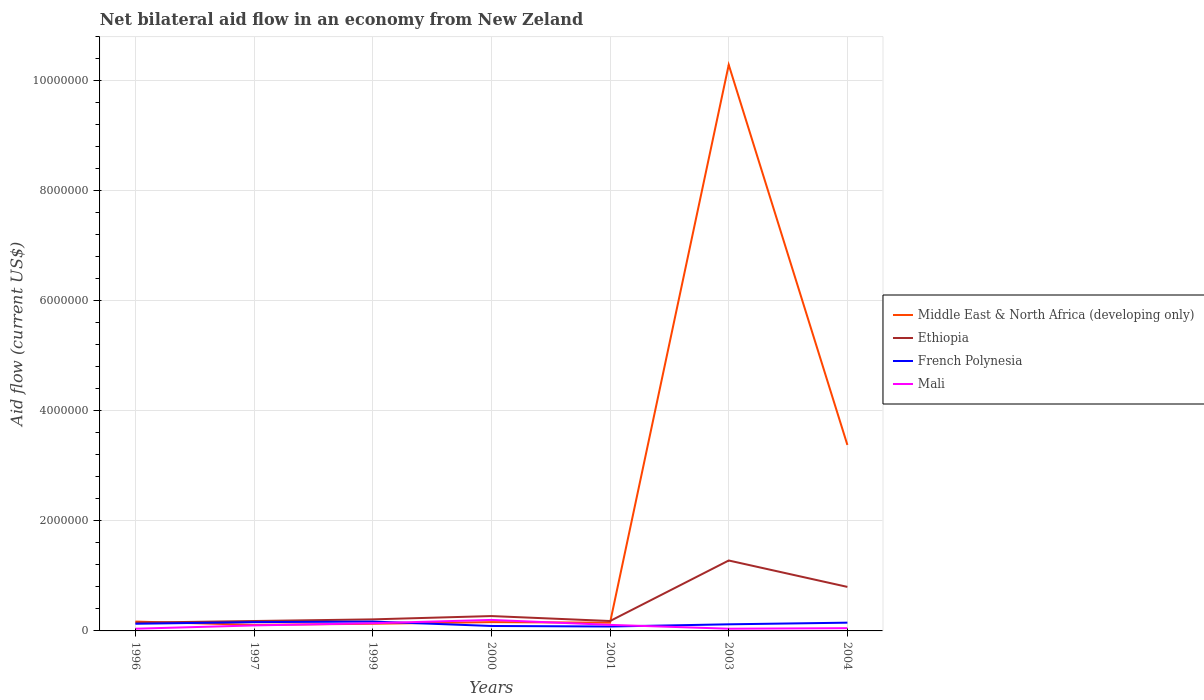Does the line corresponding to French Polynesia intersect with the line corresponding to Mali?
Your response must be concise. Yes. In which year was the net bilateral aid flow in Ethiopia maximum?
Offer a terse response. 1996. What is the difference between the highest and the second highest net bilateral aid flow in Middle East & North Africa (developing only)?
Provide a short and direct response. 1.02e+07. Is the net bilateral aid flow in Mali strictly greater than the net bilateral aid flow in Ethiopia over the years?
Give a very brief answer. Yes. How many lines are there?
Provide a short and direct response. 4. How many years are there in the graph?
Make the answer very short. 7. What is the difference between two consecutive major ticks on the Y-axis?
Give a very brief answer. 2.00e+06. Does the graph contain grids?
Provide a succinct answer. Yes. Where does the legend appear in the graph?
Provide a short and direct response. Center right. How are the legend labels stacked?
Your answer should be compact. Vertical. What is the title of the graph?
Offer a very short reply. Net bilateral aid flow in an economy from New Zeland. What is the label or title of the Y-axis?
Your response must be concise. Aid flow (current US$). What is the Aid flow (current US$) of Middle East & North Africa (developing only) in 1996?
Offer a terse response. 1.70e+05. What is the Aid flow (current US$) of Ethiopia in 1996?
Provide a succinct answer. 1.50e+05. What is the Aid flow (current US$) in Mali in 1996?
Offer a terse response. 4.00e+04. What is the Aid flow (current US$) in Mali in 1997?
Provide a short and direct response. 1.00e+05. What is the Aid flow (current US$) of Ethiopia in 1999?
Ensure brevity in your answer.  2.10e+05. What is the Aid flow (current US$) of French Polynesia in 1999?
Keep it short and to the point. 1.70e+05. What is the Aid flow (current US$) of Middle East & North Africa (developing only) in 2000?
Your response must be concise. 1.60e+05. What is the Aid flow (current US$) of French Polynesia in 2000?
Offer a terse response. 9.00e+04. What is the Aid flow (current US$) in Middle East & North Africa (developing only) in 2001?
Provide a short and direct response. 1.50e+05. What is the Aid flow (current US$) of Ethiopia in 2001?
Your answer should be compact. 1.80e+05. What is the Aid flow (current US$) of French Polynesia in 2001?
Ensure brevity in your answer.  8.00e+04. What is the Aid flow (current US$) in Mali in 2001?
Ensure brevity in your answer.  1.10e+05. What is the Aid flow (current US$) of Middle East & North Africa (developing only) in 2003?
Offer a terse response. 1.03e+07. What is the Aid flow (current US$) of Ethiopia in 2003?
Your answer should be very brief. 1.28e+06. What is the Aid flow (current US$) in Middle East & North Africa (developing only) in 2004?
Make the answer very short. 3.38e+06. What is the Aid flow (current US$) of French Polynesia in 2004?
Give a very brief answer. 1.50e+05. Across all years, what is the maximum Aid flow (current US$) in Middle East & North Africa (developing only)?
Your answer should be very brief. 1.03e+07. Across all years, what is the maximum Aid flow (current US$) of Ethiopia?
Your answer should be very brief. 1.28e+06. Across all years, what is the maximum Aid flow (current US$) in French Polynesia?
Offer a terse response. 1.70e+05. Across all years, what is the maximum Aid flow (current US$) of Mali?
Make the answer very short. 2.00e+05. Across all years, what is the minimum Aid flow (current US$) in Middle East & North Africa (developing only)?
Offer a terse response. 1.10e+05. Across all years, what is the minimum Aid flow (current US$) in Ethiopia?
Make the answer very short. 1.50e+05. Across all years, what is the minimum Aid flow (current US$) of French Polynesia?
Ensure brevity in your answer.  8.00e+04. What is the total Aid flow (current US$) of Middle East & North Africa (developing only) in the graph?
Your answer should be compact. 1.44e+07. What is the total Aid flow (current US$) in Ethiopia in the graph?
Make the answer very short. 3.07e+06. What is the total Aid flow (current US$) in Mali in the graph?
Your response must be concise. 6.80e+05. What is the difference between the Aid flow (current US$) in Middle East & North Africa (developing only) in 1996 and that in 1997?
Keep it short and to the point. 6.00e+04. What is the difference between the Aid flow (current US$) of Ethiopia in 1996 and that in 1997?
Your answer should be very brief. -3.00e+04. What is the difference between the Aid flow (current US$) in French Polynesia in 1996 and that in 1997?
Your answer should be very brief. -3.00e+04. What is the difference between the Aid flow (current US$) in Middle East & North Africa (developing only) in 1996 and that in 1999?
Your response must be concise. 4.00e+04. What is the difference between the Aid flow (current US$) of Mali in 1996 and that in 1999?
Offer a very short reply. -1.00e+05. What is the difference between the Aid flow (current US$) in Middle East & North Africa (developing only) in 1996 and that in 2000?
Your response must be concise. 10000. What is the difference between the Aid flow (current US$) in Ethiopia in 1996 and that in 2000?
Keep it short and to the point. -1.20e+05. What is the difference between the Aid flow (current US$) of French Polynesia in 1996 and that in 2000?
Give a very brief answer. 4.00e+04. What is the difference between the Aid flow (current US$) of Mali in 1996 and that in 2000?
Keep it short and to the point. -1.60e+05. What is the difference between the Aid flow (current US$) in Middle East & North Africa (developing only) in 1996 and that in 2001?
Offer a very short reply. 2.00e+04. What is the difference between the Aid flow (current US$) of Mali in 1996 and that in 2001?
Give a very brief answer. -7.00e+04. What is the difference between the Aid flow (current US$) in Middle East & North Africa (developing only) in 1996 and that in 2003?
Offer a terse response. -1.01e+07. What is the difference between the Aid flow (current US$) in Ethiopia in 1996 and that in 2003?
Ensure brevity in your answer.  -1.13e+06. What is the difference between the Aid flow (current US$) in Mali in 1996 and that in 2003?
Provide a short and direct response. 0. What is the difference between the Aid flow (current US$) of Middle East & North Africa (developing only) in 1996 and that in 2004?
Make the answer very short. -3.21e+06. What is the difference between the Aid flow (current US$) of Ethiopia in 1996 and that in 2004?
Your answer should be compact. -6.50e+05. What is the difference between the Aid flow (current US$) of French Polynesia in 1996 and that in 2004?
Provide a succinct answer. -2.00e+04. What is the difference between the Aid flow (current US$) of Middle East & North Africa (developing only) in 1997 and that in 1999?
Offer a terse response. -2.00e+04. What is the difference between the Aid flow (current US$) in Ethiopia in 1997 and that in 1999?
Offer a terse response. -3.00e+04. What is the difference between the Aid flow (current US$) of French Polynesia in 1997 and that in 1999?
Ensure brevity in your answer.  -10000. What is the difference between the Aid flow (current US$) in Middle East & North Africa (developing only) in 1997 and that in 2000?
Ensure brevity in your answer.  -5.00e+04. What is the difference between the Aid flow (current US$) of Ethiopia in 1997 and that in 2000?
Ensure brevity in your answer.  -9.00e+04. What is the difference between the Aid flow (current US$) in Mali in 1997 and that in 2000?
Offer a very short reply. -1.00e+05. What is the difference between the Aid flow (current US$) of Middle East & North Africa (developing only) in 1997 and that in 2001?
Your answer should be compact. -4.00e+04. What is the difference between the Aid flow (current US$) in Ethiopia in 1997 and that in 2001?
Provide a succinct answer. 0. What is the difference between the Aid flow (current US$) of French Polynesia in 1997 and that in 2001?
Offer a very short reply. 8.00e+04. What is the difference between the Aid flow (current US$) in Mali in 1997 and that in 2001?
Offer a terse response. -10000. What is the difference between the Aid flow (current US$) of Middle East & North Africa (developing only) in 1997 and that in 2003?
Ensure brevity in your answer.  -1.02e+07. What is the difference between the Aid flow (current US$) of Ethiopia in 1997 and that in 2003?
Give a very brief answer. -1.10e+06. What is the difference between the Aid flow (current US$) of Middle East & North Africa (developing only) in 1997 and that in 2004?
Your answer should be very brief. -3.27e+06. What is the difference between the Aid flow (current US$) in Ethiopia in 1997 and that in 2004?
Offer a very short reply. -6.20e+05. What is the difference between the Aid flow (current US$) of Mali in 1997 and that in 2004?
Offer a very short reply. 5.00e+04. What is the difference between the Aid flow (current US$) in Ethiopia in 1999 and that in 2000?
Offer a very short reply. -6.00e+04. What is the difference between the Aid flow (current US$) of French Polynesia in 1999 and that in 2000?
Offer a very short reply. 8.00e+04. What is the difference between the Aid flow (current US$) of Middle East & North Africa (developing only) in 1999 and that in 2001?
Give a very brief answer. -2.00e+04. What is the difference between the Aid flow (current US$) in Ethiopia in 1999 and that in 2001?
Offer a terse response. 3.00e+04. What is the difference between the Aid flow (current US$) of French Polynesia in 1999 and that in 2001?
Your response must be concise. 9.00e+04. What is the difference between the Aid flow (current US$) of Mali in 1999 and that in 2001?
Your answer should be compact. 3.00e+04. What is the difference between the Aid flow (current US$) in Middle East & North Africa (developing only) in 1999 and that in 2003?
Provide a short and direct response. -1.02e+07. What is the difference between the Aid flow (current US$) in Ethiopia in 1999 and that in 2003?
Give a very brief answer. -1.07e+06. What is the difference between the Aid flow (current US$) in Mali in 1999 and that in 2003?
Offer a very short reply. 1.00e+05. What is the difference between the Aid flow (current US$) in Middle East & North Africa (developing only) in 1999 and that in 2004?
Offer a terse response. -3.25e+06. What is the difference between the Aid flow (current US$) in Ethiopia in 1999 and that in 2004?
Give a very brief answer. -5.90e+05. What is the difference between the Aid flow (current US$) of French Polynesia in 1999 and that in 2004?
Keep it short and to the point. 2.00e+04. What is the difference between the Aid flow (current US$) of Mali in 1999 and that in 2004?
Ensure brevity in your answer.  9.00e+04. What is the difference between the Aid flow (current US$) in Middle East & North Africa (developing only) in 2000 and that in 2001?
Offer a terse response. 10000. What is the difference between the Aid flow (current US$) in Ethiopia in 2000 and that in 2001?
Give a very brief answer. 9.00e+04. What is the difference between the Aid flow (current US$) in French Polynesia in 2000 and that in 2001?
Ensure brevity in your answer.  10000. What is the difference between the Aid flow (current US$) in Middle East & North Africa (developing only) in 2000 and that in 2003?
Provide a short and direct response. -1.01e+07. What is the difference between the Aid flow (current US$) in Ethiopia in 2000 and that in 2003?
Offer a terse response. -1.01e+06. What is the difference between the Aid flow (current US$) of French Polynesia in 2000 and that in 2003?
Your response must be concise. -3.00e+04. What is the difference between the Aid flow (current US$) in Middle East & North Africa (developing only) in 2000 and that in 2004?
Give a very brief answer. -3.22e+06. What is the difference between the Aid flow (current US$) of Ethiopia in 2000 and that in 2004?
Ensure brevity in your answer.  -5.30e+05. What is the difference between the Aid flow (current US$) in French Polynesia in 2000 and that in 2004?
Give a very brief answer. -6.00e+04. What is the difference between the Aid flow (current US$) in Middle East & North Africa (developing only) in 2001 and that in 2003?
Offer a terse response. -1.01e+07. What is the difference between the Aid flow (current US$) in Ethiopia in 2001 and that in 2003?
Your answer should be very brief. -1.10e+06. What is the difference between the Aid flow (current US$) of Middle East & North Africa (developing only) in 2001 and that in 2004?
Make the answer very short. -3.23e+06. What is the difference between the Aid flow (current US$) in Ethiopia in 2001 and that in 2004?
Your response must be concise. -6.20e+05. What is the difference between the Aid flow (current US$) in French Polynesia in 2001 and that in 2004?
Give a very brief answer. -7.00e+04. What is the difference between the Aid flow (current US$) of Middle East & North Africa (developing only) in 2003 and that in 2004?
Offer a terse response. 6.91e+06. What is the difference between the Aid flow (current US$) in Mali in 2003 and that in 2004?
Ensure brevity in your answer.  -10000. What is the difference between the Aid flow (current US$) in Middle East & North Africa (developing only) in 1996 and the Aid flow (current US$) in French Polynesia in 1997?
Your answer should be very brief. 10000. What is the difference between the Aid flow (current US$) of Middle East & North Africa (developing only) in 1996 and the Aid flow (current US$) of Mali in 1997?
Your answer should be compact. 7.00e+04. What is the difference between the Aid flow (current US$) in Ethiopia in 1996 and the Aid flow (current US$) in Mali in 1997?
Give a very brief answer. 5.00e+04. What is the difference between the Aid flow (current US$) in Middle East & North Africa (developing only) in 1996 and the Aid flow (current US$) in French Polynesia in 1999?
Offer a terse response. 0. What is the difference between the Aid flow (current US$) in French Polynesia in 1996 and the Aid flow (current US$) in Mali in 1999?
Ensure brevity in your answer.  -10000. What is the difference between the Aid flow (current US$) of Middle East & North Africa (developing only) in 1996 and the Aid flow (current US$) of Ethiopia in 2000?
Make the answer very short. -1.00e+05. What is the difference between the Aid flow (current US$) in Middle East & North Africa (developing only) in 1996 and the Aid flow (current US$) in French Polynesia in 2000?
Provide a succinct answer. 8.00e+04. What is the difference between the Aid flow (current US$) of Ethiopia in 1996 and the Aid flow (current US$) of French Polynesia in 2000?
Ensure brevity in your answer.  6.00e+04. What is the difference between the Aid flow (current US$) of Middle East & North Africa (developing only) in 1996 and the Aid flow (current US$) of Ethiopia in 2001?
Offer a terse response. -10000. What is the difference between the Aid flow (current US$) in Middle East & North Africa (developing only) in 1996 and the Aid flow (current US$) in French Polynesia in 2001?
Offer a very short reply. 9.00e+04. What is the difference between the Aid flow (current US$) in Ethiopia in 1996 and the Aid flow (current US$) in French Polynesia in 2001?
Provide a succinct answer. 7.00e+04. What is the difference between the Aid flow (current US$) in French Polynesia in 1996 and the Aid flow (current US$) in Mali in 2001?
Make the answer very short. 2.00e+04. What is the difference between the Aid flow (current US$) in Middle East & North Africa (developing only) in 1996 and the Aid flow (current US$) in Ethiopia in 2003?
Make the answer very short. -1.11e+06. What is the difference between the Aid flow (current US$) in Middle East & North Africa (developing only) in 1996 and the Aid flow (current US$) in Ethiopia in 2004?
Make the answer very short. -6.30e+05. What is the difference between the Aid flow (current US$) in Middle East & North Africa (developing only) in 1996 and the Aid flow (current US$) in Mali in 2004?
Ensure brevity in your answer.  1.20e+05. What is the difference between the Aid flow (current US$) of French Polynesia in 1996 and the Aid flow (current US$) of Mali in 2004?
Ensure brevity in your answer.  8.00e+04. What is the difference between the Aid flow (current US$) in Middle East & North Africa (developing only) in 1997 and the Aid flow (current US$) in Ethiopia in 1999?
Your answer should be very brief. -1.00e+05. What is the difference between the Aid flow (current US$) in Middle East & North Africa (developing only) in 1997 and the Aid flow (current US$) in French Polynesia in 1999?
Provide a succinct answer. -6.00e+04. What is the difference between the Aid flow (current US$) of Middle East & North Africa (developing only) in 1997 and the Aid flow (current US$) of Mali in 1999?
Ensure brevity in your answer.  -3.00e+04. What is the difference between the Aid flow (current US$) of Ethiopia in 1997 and the Aid flow (current US$) of French Polynesia in 1999?
Keep it short and to the point. 10000. What is the difference between the Aid flow (current US$) in Ethiopia in 1997 and the Aid flow (current US$) in Mali in 1999?
Make the answer very short. 4.00e+04. What is the difference between the Aid flow (current US$) in Middle East & North Africa (developing only) in 1997 and the Aid flow (current US$) in Ethiopia in 2000?
Ensure brevity in your answer.  -1.60e+05. What is the difference between the Aid flow (current US$) of Middle East & North Africa (developing only) in 1997 and the Aid flow (current US$) of French Polynesia in 2000?
Offer a terse response. 2.00e+04. What is the difference between the Aid flow (current US$) in Middle East & North Africa (developing only) in 1997 and the Aid flow (current US$) in Mali in 2000?
Keep it short and to the point. -9.00e+04. What is the difference between the Aid flow (current US$) in Ethiopia in 1997 and the Aid flow (current US$) in French Polynesia in 2000?
Make the answer very short. 9.00e+04. What is the difference between the Aid flow (current US$) in Middle East & North Africa (developing only) in 1997 and the Aid flow (current US$) in French Polynesia in 2001?
Ensure brevity in your answer.  3.00e+04. What is the difference between the Aid flow (current US$) in French Polynesia in 1997 and the Aid flow (current US$) in Mali in 2001?
Provide a short and direct response. 5.00e+04. What is the difference between the Aid flow (current US$) in Middle East & North Africa (developing only) in 1997 and the Aid flow (current US$) in Ethiopia in 2003?
Your response must be concise. -1.17e+06. What is the difference between the Aid flow (current US$) of Middle East & North Africa (developing only) in 1997 and the Aid flow (current US$) of French Polynesia in 2003?
Provide a succinct answer. -10000. What is the difference between the Aid flow (current US$) of Ethiopia in 1997 and the Aid flow (current US$) of Mali in 2003?
Provide a short and direct response. 1.40e+05. What is the difference between the Aid flow (current US$) of French Polynesia in 1997 and the Aid flow (current US$) of Mali in 2003?
Provide a short and direct response. 1.20e+05. What is the difference between the Aid flow (current US$) in Middle East & North Africa (developing only) in 1997 and the Aid flow (current US$) in Ethiopia in 2004?
Make the answer very short. -6.90e+05. What is the difference between the Aid flow (current US$) of Ethiopia in 1997 and the Aid flow (current US$) of Mali in 2004?
Your response must be concise. 1.30e+05. What is the difference between the Aid flow (current US$) of Middle East & North Africa (developing only) in 1999 and the Aid flow (current US$) of Ethiopia in 2000?
Provide a succinct answer. -1.40e+05. What is the difference between the Aid flow (current US$) of Middle East & North Africa (developing only) in 1999 and the Aid flow (current US$) of Mali in 2000?
Ensure brevity in your answer.  -7.00e+04. What is the difference between the Aid flow (current US$) of Ethiopia in 1999 and the Aid flow (current US$) of French Polynesia in 2000?
Provide a short and direct response. 1.20e+05. What is the difference between the Aid flow (current US$) in French Polynesia in 1999 and the Aid flow (current US$) in Mali in 2000?
Your answer should be compact. -3.00e+04. What is the difference between the Aid flow (current US$) of Ethiopia in 1999 and the Aid flow (current US$) of Mali in 2001?
Give a very brief answer. 1.00e+05. What is the difference between the Aid flow (current US$) in Middle East & North Africa (developing only) in 1999 and the Aid flow (current US$) in Ethiopia in 2003?
Ensure brevity in your answer.  -1.15e+06. What is the difference between the Aid flow (current US$) of Middle East & North Africa (developing only) in 1999 and the Aid flow (current US$) of French Polynesia in 2003?
Give a very brief answer. 10000. What is the difference between the Aid flow (current US$) in Middle East & North Africa (developing only) in 1999 and the Aid flow (current US$) in Mali in 2003?
Offer a very short reply. 9.00e+04. What is the difference between the Aid flow (current US$) of Middle East & North Africa (developing only) in 1999 and the Aid flow (current US$) of Ethiopia in 2004?
Ensure brevity in your answer.  -6.70e+05. What is the difference between the Aid flow (current US$) of Middle East & North Africa (developing only) in 1999 and the Aid flow (current US$) of Mali in 2004?
Offer a terse response. 8.00e+04. What is the difference between the Aid flow (current US$) in Middle East & North Africa (developing only) in 2000 and the Aid flow (current US$) in French Polynesia in 2001?
Keep it short and to the point. 8.00e+04. What is the difference between the Aid flow (current US$) of French Polynesia in 2000 and the Aid flow (current US$) of Mali in 2001?
Ensure brevity in your answer.  -2.00e+04. What is the difference between the Aid flow (current US$) of Middle East & North Africa (developing only) in 2000 and the Aid flow (current US$) of Ethiopia in 2003?
Offer a very short reply. -1.12e+06. What is the difference between the Aid flow (current US$) of Middle East & North Africa (developing only) in 2000 and the Aid flow (current US$) of Mali in 2003?
Ensure brevity in your answer.  1.20e+05. What is the difference between the Aid flow (current US$) in Ethiopia in 2000 and the Aid flow (current US$) in French Polynesia in 2003?
Your answer should be very brief. 1.50e+05. What is the difference between the Aid flow (current US$) in French Polynesia in 2000 and the Aid flow (current US$) in Mali in 2003?
Give a very brief answer. 5.00e+04. What is the difference between the Aid flow (current US$) in Middle East & North Africa (developing only) in 2000 and the Aid flow (current US$) in Ethiopia in 2004?
Give a very brief answer. -6.40e+05. What is the difference between the Aid flow (current US$) of Middle East & North Africa (developing only) in 2000 and the Aid flow (current US$) of Mali in 2004?
Your answer should be compact. 1.10e+05. What is the difference between the Aid flow (current US$) of Ethiopia in 2000 and the Aid flow (current US$) of French Polynesia in 2004?
Your response must be concise. 1.20e+05. What is the difference between the Aid flow (current US$) in Ethiopia in 2000 and the Aid flow (current US$) in Mali in 2004?
Your response must be concise. 2.20e+05. What is the difference between the Aid flow (current US$) in Middle East & North Africa (developing only) in 2001 and the Aid flow (current US$) in Ethiopia in 2003?
Offer a terse response. -1.13e+06. What is the difference between the Aid flow (current US$) of Middle East & North Africa (developing only) in 2001 and the Aid flow (current US$) of Ethiopia in 2004?
Make the answer very short. -6.50e+05. What is the difference between the Aid flow (current US$) of Middle East & North Africa (developing only) in 2001 and the Aid flow (current US$) of Mali in 2004?
Your response must be concise. 1.00e+05. What is the difference between the Aid flow (current US$) in Ethiopia in 2001 and the Aid flow (current US$) in French Polynesia in 2004?
Your response must be concise. 3.00e+04. What is the difference between the Aid flow (current US$) of Ethiopia in 2001 and the Aid flow (current US$) of Mali in 2004?
Your answer should be compact. 1.30e+05. What is the difference between the Aid flow (current US$) of French Polynesia in 2001 and the Aid flow (current US$) of Mali in 2004?
Ensure brevity in your answer.  3.00e+04. What is the difference between the Aid flow (current US$) of Middle East & North Africa (developing only) in 2003 and the Aid flow (current US$) of Ethiopia in 2004?
Offer a very short reply. 9.49e+06. What is the difference between the Aid flow (current US$) in Middle East & North Africa (developing only) in 2003 and the Aid flow (current US$) in French Polynesia in 2004?
Offer a terse response. 1.01e+07. What is the difference between the Aid flow (current US$) in Middle East & North Africa (developing only) in 2003 and the Aid flow (current US$) in Mali in 2004?
Your answer should be very brief. 1.02e+07. What is the difference between the Aid flow (current US$) in Ethiopia in 2003 and the Aid flow (current US$) in French Polynesia in 2004?
Your answer should be very brief. 1.13e+06. What is the difference between the Aid flow (current US$) in Ethiopia in 2003 and the Aid flow (current US$) in Mali in 2004?
Provide a short and direct response. 1.23e+06. What is the difference between the Aid flow (current US$) in French Polynesia in 2003 and the Aid flow (current US$) in Mali in 2004?
Provide a succinct answer. 7.00e+04. What is the average Aid flow (current US$) of Middle East & North Africa (developing only) per year?
Offer a terse response. 2.06e+06. What is the average Aid flow (current US$) in Ethiopia per year?
Provide a succinct answer. 4.39e+05. What is the average Aid flow (current US$) in French Polynesia per year?
Your answer should be compact. 1.29e+05. What is the average Aid flow (current US$) of Mali per year?
Your answer should be compact. 9.71e+04. In the year 1996, what is the difference between the Aid flow (current US$) in Middle East & North Africa (developing only) and Aid flow (current US$) in Mali?
Your response must be concise. 1.30e+05. In the year 1997, what is the difference between the Aid flow (current US$) of Middle East & North Africa (developing only) and Aid flow (current US$) of Ethiopia?
Your answer should be very brief. -7.00e+04. In the year 1997, what is the difference between the Aid flow (current US$) in Middle East & North Africa (developing only) and Aid flow (current US$) in Mali?
Your response must be concise. 10000. In the year 1997, what is the difference between the Aid flow (current US$) of French Polynesia and Aid flow (current US$) of Mali?
Give a very brief answer. 6.00e+04. In the year 1999, what is the difference between the Aid flow (current US$) in Middle East & North Africa (developing only) and Aid flow (current US$) in Mali?
Ensure brevity in your answer.  -10000. In the year 1999, what is the difference between the Aid flow (current US$) of Ethiopia and Aid flow (current US$) of French Polynesia?
Your answer should be compact. 4.00e+04. In the year 1999, what is the difference between the Aid flow (current US$) of French Polynesia and Aid flow (current US$) of Mali?
Your answer should be compact. 3.00e+04. In the year 2000, what is the difference between the Aid flow (current US$) of Middle East & North Africa (developing only) and Aid flow (current US$) of French Polynesia?
Provide a short and direct response. 7.00e+04. In the year 2000, what is the difference between the Aid flow (current US$) of Ethiopia and Aid flow (current US$) of Mali?
Provide a succinct answer. 7.00e+04. In the year 2001, what is the difference between the Aid flow (current US$) in Middle East & North Africa (developing only) and Aid flow (current US$) in Ethiopia?
Your response must be concise. -3.00e+04. In the year 2001, what is the difference between the Aid flow (current US$) of Ethiopia and Aid flow (current US$) of French Polynesia?
Provide a succinct answer. 1.00e+05. In the year 2001, what is the difference between the Aid flow (current US$) of Ethiopia and Aid flow (current US$) of Mali?
Make the answer very short. 7.00e+04. In the year 2001, what is the difference between the Aid flow (current US$) in French Polynesia and Aid flow (current US$) in Mali?
Offer a terse response. -3.00e+04. In the year 2003, what is the difference between the Aid flow (current US$) in Middle East & North Africa (developing only) and Aid flow (current US$) in Ethiopia?
Make the answer very short. 9.01e+06. In the year 2003, what is the difference between the Aid flow (current US$) of Middle East & North Africa (developing only) and Aid flow (current US$) of French Polynesia?
Keep it short and to the point. 1.02e+07. In the year 2003, what is the difference between the Aid flow (current US$) in Middle East & North Africa (developing only) and Aid flow (current US$) in Mali?
Offer a terse response. 1.02e+07. In the year 2003, what is the difference between the Aid flow (current US$) of Ethiopia and Aid flow (current US$) of French Polynesia?
Keep it short and to the point. 1.16e+06. In the year 2003, what is the difference between the Aid flow (current US$) in Ethiopia and Aid flow (current US$) in Mali?
Provide a short and direct response. 1.24e+06. In the year 2004, what is the difference between the Aid flow (current US$) of Middle East & North Africa (developing only) and Aid flow (current US$) of Ethiopia?
Your answer should be very brief. 2.58e+06. In the year 2004, what is the difference between the Aid flow (current US$) of Middle East & North Africa (developing only) and Aid flow (current US$) of French Polynesia?
Give a very brief answer. 3.23e+06. In the year 2004, what is the difference between the Aid flow (current US$) of Middle East & North Africa (developing only) and Aid flow (current US$) of Mali?
Provide a short and direct response. 3.33e+06. In the year 2004, what is the difference between the Aid flow (current US$) of Ethiopia and Aid flow (current US$) of French Polynesia?
Provide a short and direct response. 6.50e+05. In the year 2004, what is the difference between the Aid flow (current US$) of Ethiopia and Aid flow (current US$) of Mali?
Offer a terse response. 7.50e+05. What is the ratio of the Aid flow (current US$) of Middle East & North Africa (developing only) in 1996 to that in 1997?
Your answer should be very brief. 1.55. What is the ratio of the Aid flow (current US$) in French Polynesia in 1996 to that in 1997?
Give a very brief answer. 0.81. What is the ratio of the Aid flow (current US$) in Mali in 1996 to that in 1997?
Keep it short and to the point. 0.4. What is the ratio of the Aid flow (current US$) in Middle East & North Africa (developing only) in 1996 to that in 1999?
Offer a very short reply. 1.31. What is the ratio of the Aid flow (current US$) of Ethiopia in 1996 to that in 1999?
Provide a short and direct response. 0.71. What is the ratio of the Aid flow (current US$) of French Polynesia in 1996 to that in 1999?
Make the answer very short. 0.76. What is the ratio of the Aid flow (current US$) in Mali in 1996 to that in 1999?
Provide a succinct answer. 0.29. What is the ratio of the Aid flow (current US$) of Ethiopia in 1996 to that in 2000?
Your answer should be compact. 0.56. What is the ratio of the Aid flow (current US$) of French Polynesia in 1996 to that in 2000?
Keep it short and to the point. 1.44. What is the ratio of the Aid flow (current US$) of Mali in 1996 to that in 2000?
Your answer should be compact. 0.2. What is the ratio of the Aid flow (current US$) in Middle East & North Africa (developing only) in 1996 to that in 2001?
Offer a very short reply. 1.13. What is the ratio of the Aid flow (current US$) in Ethiopia in 1996 to that in 2001?
Your answer should be compact. 0.83. What is the ratio of the Aid flow (current US$) in French Polynesia in 1996 to that in 2001?
Keep it short and to the point. 1.62. What is the ratio of the Aid flow (current US$) in Mali in 1996 to that in 2001?
Keep it short and to the point. 0.36. What is the ratio of the Aid flow (current US$) of Middle East & North Africa (developing only) in 1996 to that in 2003?
Ensure brevity in your answer.  0.02. What is the ratio of the Aid flow (current US$) in Ethiopia in 1996 to that in 2003?
Give a very brief answer. 0.12. What is the ratio of the Aid flow (current US$) in Middle East & North Africa (developing only) in 1996 to that in 2004?
Make the answer very short. 0.05. What is the ratio of the Aid flow (current US$) of Ethiopia in 1996 to that in 2004?
Offer a very short reply. 0.19. What is the ratio of the Aid flow (current US$) in French Polynesia in 1996 to that in 2004?
Your response must be concise. 0.87. What is the ratio of the Aid flow (current US$) in Middle East & North Africa (developing only) in 1997 to that in 1999?
Your response must be concise. 0.85. What is the ratio of the Aid flow (current US$) in Ethiopia in 1997 to that in 1999?
Your answer should be compact. 0.86. What is the ratio of the Aid flow (current US$) in Mali in 1997 to that in 1999?
Offer a very short reply. 0.71. What is the ratio of the Aid flow (current US$) in Middle East & North Africa (developing only) in 1997 to that in 2000?
Make the answer very short. 0.69. What is the ratio of the Aid flow (current US$) in French Polynesia in 1997 to that in 2000?
Provide a succinct answer. 1.78. What is the ratio of the Aid flow (current US$) of Middle East & North Africa (developing only) in 1997 to that in 2001?
Ensure brevity in your answer.  0.73. What is the ratio of the Aid flow (current US$) of Ethiopia in 1997 to that in 2001?
Provide a short and direct response. 1. What is the ratio of the Aid flow (current US$) in French Polynesia in 1997 to that in 2001?
Ensure brevity in your answer.  2. What is the ratio of the Aid flow (current US$) in Middle East & North Africa (developing only) in 1997 to that in 2003?
Provide a succinct answer. 0.01. What is the ratio of the Aid flow (current US$) in Ethiopia in 1997 to that in 2003?
Offer a very short reply. 0.14. What is the ratio of the Aid flow (current US$) in French Polynesia in 1997 to that in 2003?
Provide a short and direct response. 1.33. What is the ratio of the Aid flow (current US$) in Middle East & North Africa (developing only) in 1997 to that in 2004?
Your response must be concise. 0.03. What is the ratio of the Aid flow (current US$) of Ethiopia in 1997 to that in 2004?
Make the answer very short. 0.23. What is the ratio of the Aid flow (current US$) of French Polynesia in 1997 to that in 2004?
Your response must be concise. 1.07. What is the ratio of the Aid flow (current US$) in Mali in 1997 to that in 2004?
Offer a terse response. 2. What is the ratio of the Aid flow (current US$) in Middle East & North Africa (developing only) in 1999 to that in 2000?
Give a very brief answer. 0.81. What is the ratio of the Aid flow (current US$) of Ethiopia in 1999 to that in 2000?
Keep it short and to the point. 0.78. What is the ratio of the Aid flow (current US$) of French Polynesia in 1999 to that in 2000?
Your answer should be compact. 1.89. What is the ratio of the Aid flow (current US$) in Mali in 1999 to that in 2000?
Provide a succinct answer. 0.7. What is the ratio of the Aid flow (current US$) of Middle East & North Africa (developing only) in 1999 to that in 2001?
Ensure brevity in your answer.  0.87. What is the ratio of the Aid flow (current US$) in French Polynesia in 1999 to that in 2001?
Offer a very short reply. 2.12. What is the ratio of the Aid flow (current US$) of Mali in 1999 to that in 2001?
Offer a very short reply. 1.27. What is the ratio of the Aid flow (current US$) of Middle East & North Africa (developing only) in 1999 to that in 2003?
Give a very brief answer. 0.01. What is the ratio of the Aid flow (current US$) in Ethiopia in 1999 to that in 2003?
Provide a succinct answer. 0.16. What is the ratio of the Aid flow (current US$) in French Polynesia in 1999 to that in 2003?
Your answer should be compact. 1.42. What is the ratio of the Aid flow (current US$) of Middle East & North Africa (developing only) in 1999 to that in 2004?
Your response must be concise. 0.04. What is the ratio of the Aid flow (current US$) of Ethiopia in 1999 to that in 2004?
Give a very brief answer. 0.26. What is the ratio of the Aid flow (current US$) of French Polynesia in 1999 to that in 2004?
Keep it short and to the point. 1.13. What is the ratio of the Aid flow (current US$) in Middle East & North Africa (developing only) in 2000 to that in 2001?
Provide a succinct answer. 1.07. What is the ratio of the Aid flow (current US$) in Mali in 2000 to that in 2001?
Your response must be concise. 1.82. What is the ratio of the Aid flow (current US$) in Middle East & North Africa (developing only) in 2000 to that in 2003?
Your response must be concise. 0.02. What is the ratio of the Aid flow (current US$) in Ethiopia in 2000 to that in 2003?
Your answer should be compact. 0.21. What is the ratio of the Aid flow (current US$) of French Polynesia in 2000 to that in 2003?
Give a very brief answer. 0.75. What is the ratio of the Aid flow (current US$) of Mali in 2000 to that in 2003?
Provide a succinct answer. 5. What is the ratio of the Aid flow (current US$) in Middle East & North Africa (developing only) in 2000 to that in 2004?
Your answer should be compact. 0.05. What is the ratio of the Aid flow (current US$) in Ethiopia in 2000 to that in 2004?
Your answer should be compact. 0.34. What is the ratio of the Aid flow (current US$) of Middle East & North Africa (developing only) in 2001 to that in 2003?
Your answer should be compact. 0.01. What is the ratio of the Aid flow (current US$) in Ethiopia in 2001 to that in 2003?
Make the answer very short. 0.14. What is the ratio of the Aid flow (current US$) in Mali in 2001 to that in 2003?
Your answer should be compact. 2.75. What is the ratio of the Aid flow (current US$) of Middle East & North Africa (developing only) in 2001 to that in 2004?
Your answer should be compact. 0.04. What is the ratio of the Aid flow (current US$) of Ethiopia in 2001 to that in 2004?
Offer a terse response. 0.23. What is the ratio of the Aid flow (current US$) in French Polynesia in 2001 to that in 2004?
Your answer should be very brief. 0.53. What is the ratio of the Aid flow (current US$) in Mali in 2001 to that in 2004?
Ensure brevity in your answer.  2.2. What is the ratio of the Aid flow (current US$) in Middle East & North Africa (developing only) in 2003 to that in 2004?
Your response must be concise. 3.04. What is the ratio of the Aid flow (current US$) of Ethiopia in 2003 to that in 2004?
Give a very brief answer. 1.6. What is the ratio of the Aid flow (current US$) in French Polynesia in 2003 to that in 2004?
Make the answer very short. 0.8. What is the ratio of the Aid flow (current US$) of Mali in 2003 to that in 2004?
Offer a very short reply. 0.8. What is the difference between the highest and the second highest Aid flow (current US$) in Middle East & North Africa (developing only)?
Keep it short and to the point. 6.91e+06. What is the difference between the highest and the second highest Aid flow (current US$) in Ethiopia?
Give a very brief answer. 4.80e+05. What is the difference between the highest and the lowest Aid flow (current US$) of Middle East & North Africa (developing only)?
Give a very brief answer. 1.02e+07. What is the difference between the highest and the lowest Aid flow (current US$) of Ethiopia?
Provide a short and direct response. 1.13e+06. 